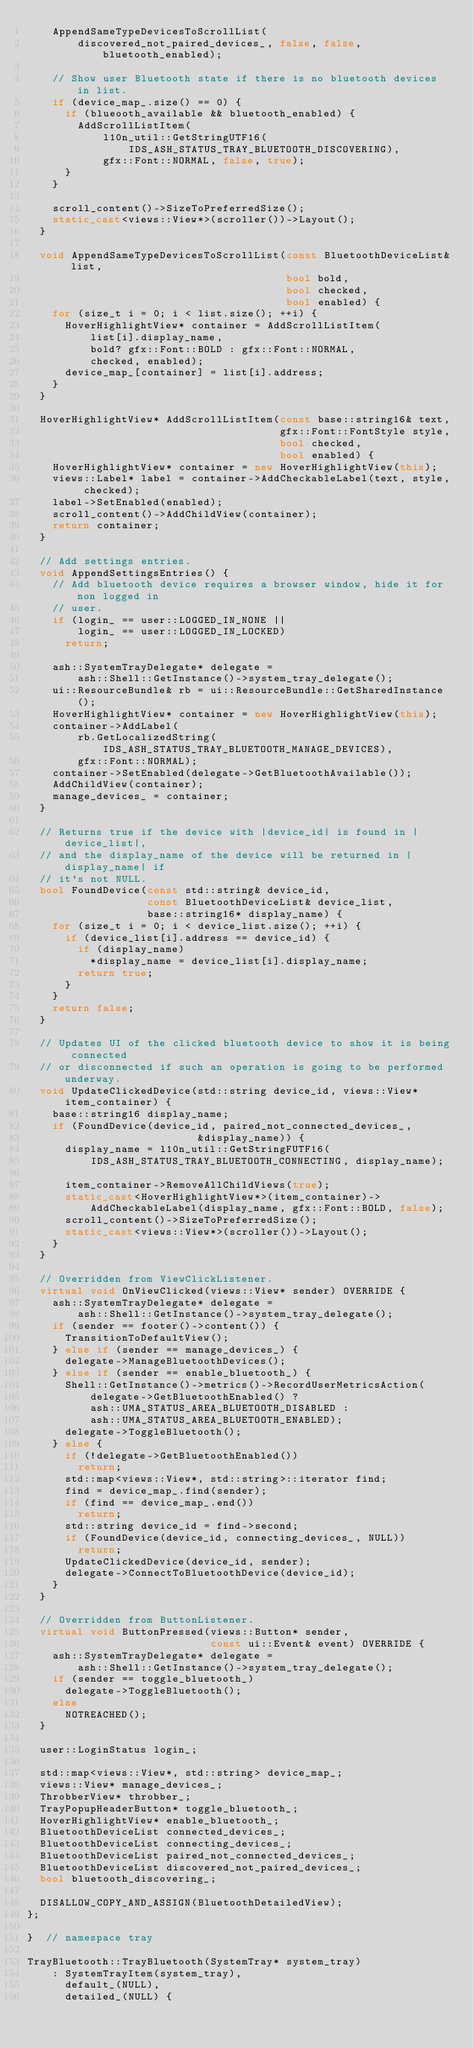<code> <loc_0><loc_0><loc_500><loc_500><_C++_>    AppendSameTypeDevicesToScrollList(
        discovered_not_paired_devices_, false, false, bluetooth_enabled);

    // Show user Bluetooth state if there is no bluetooth devices in list.
    if (device_map_.size() == 0) {
      if (blueooth_available && bluetooth_enabled) {
        AddScrollListItem(
            l10n_util::GetStringUTF16(
                IDS_ASH_STATUS_TRAY_BLUETOOTH_DISCOVERING),
            gfx::Font::NORMAL, false, true);
      }
    }

    scroll_content()->SizeToPreferredSize();
    static_cast<views::View*>(scroller())->Layout();
  }

  void AppendSameTypeDevicesToScrollList(const BluetoothDeviceList& list,
                                         bool bold,
                                         bool checked,
                                         bool enabled) {
    for (size_t i = 0; i < list.size(); ++i) {
      HoverHighlightView* container = AddScrollListItem(
          list[i].display_name,
          bold? gfx::Font::BOLD : gfx::Font::NORMAL,
          checked, enabled);
      device_map_[container] = list[i].address;
    }
  }

  HoverHighlightView* AddScrollListItem(const base::string16& text,
                                        gfx::Font::FontStyle style,
                                        bool checked,
                                        bool enabled) {
    HoverHighlightView* container = new HoverHighlightView(this);
    views::Label* label = container->AddCheckableLabel(text, style, checked);
    label->SetEnabled(enabled);
    scroll_content()->AddChildView(container);
    return container;
  }

  // Add settings entries.
  void AppendSettingsEntries() {
    // Add bluetooth device requires a browser window, hide it for non logged in
    // user.
    if (login_ == user::LOGGED_IN_NONE ||
        login_ == user::LOGGED_IN_LOCKED)
      return;

    ash::SystemTrayDelegate* delegate =
        ash::Shell::GetInstance()->system_tray_delegate();
    ui::ResourceBundle& rb = ui::ResourceBundle::GetSharedInstance();
    HoverHighlightView* container = new HoverHighlightView(this);
    container->AddLabel(
        rb.GetLocalizedString(IDS_ASH_STATUS_TRAY_BLUETOOTH_MANAGE_DEVICES),
        gfx::Font::NORMAL);
    container->SetEnabled(delegate->GetBluetoothAvailable());
    AddChildView(container);
    manage_devices_ = container;
  }

  // Returns true if the device with |device_id| is found in |device_list|,
  // and the display_name of the device will be returned in |display_name| if
  // it's not NULL.
  bool FoundDevice(const std::string& device_id,
                   const BluetoothDeviceList& device_list,
                   base::string16* display_name) {
    for (size_t i = 0; i < device_list.size(); ++i) {
      if (device_list[i].address == device_id) {
        if (display_name)
          *display_name = device_list[i].display_name;
        return true;
      }
    }
    return false;
  }

  // Updates UI of the clicked bluetooth device to show it is being connected
  // or disconnected if such an operation is going to be performed underway.
  void UpdateClickedDevice(std::string device_id, views::View* item_container) {
    base::string16 display_name;
    if (FoundDevice(device_id, paired_not_connected_devices_,
                           &display_name)) {
      display_name = l10n_util::GetStringFUTF16(
          IDS_ASH_STATUS_TRAY_BLUETOOTH_CONNECTING, display_name);

      item_container->RemoveAllChildViews(true);
      static_cast<HoverHighlightView*>(item_container)->
          AddCheckableLabel(display_name, gfx::Font::BOLD, false);
      scroll_content()->SizeToPreferredSize();
      static_cast<views::View*>(scroller())->Layout();
    }
  }

  // Overridden from ViewClickListener.
  virtual void OnViewClicked(views::View* sender) OVERRIDE {
    ash::SystemTrayDelegate* delegate =
        ash::Shell::GetInstance()->system_tray_delegate();
    if (sender == footer()->content()) {
      TransitionToDefaultView();
    } else if (sender == manage_devices_) {
      delegate->ManageBluetoothDevices();
    } else if (sender == enable_bluetooth_) {
      Shell::GetInstance()->metrics()->RecordUserMetricsAction(
          delegate->GetBluetoothEnabled() ?
          ash::UMA_STATUS_AREA_BLUETOOTH_DISABLED :
          ash::UMA_STATUS_AREA_BLUETOOTH_ENABLED);
      delegate->ToggleBluetooth();
    } else {
      if (!delegate->GetBluetoothEnabled())
        return;
      std::map<views::View*, std::string>::iterator find;
      find = device_map_.find(sender);
      if (find == device_map_.end())
        return;
      std::string device_id = find->second;
      if (FoundDevice(device_id, connecting_devices_, NULL))
        return;
      UpdateClickedDevice(device_id, sender);
      delegate->ConnectToBluetoothDevice(device_id);
    }
  }

  // Overridden from ButtonListener.
  virtual void ButtonPressed(views::Button* sender,
                             const ui::Event& event) OVERRIDE {
    ash::SystemTrayDelegate* delegate =
        ash::Shell::GetInstance()->system_tray_delegate();
    if (sender == toggle_bluetooth_)
      delegate->ToggleBluetooth();
    else
      NOTREACHED();
  }

  user::LoginStatus login_;

  std::map<views::View*, std::string> device_map_;
  views::View* manage_devices_;
  ThrobberView* throbber_;
  TrayPopupHeaderButton* toggle_bluetooth_;
  HoverHighlightView* enable_bluetooth_;
  BluetoothDeviceList connected_devices_;
  BluetoothDeviceList connecting_devices_;
  BluetoothDeviceList paired_not_connected_devices_;
  BluetoothDeviceList discovered_not_paired_devices_;
  bool bluetooth_discovering_;

  DISALLOW_COPY_AND_ASSIGN(BluetoothDetailedView);
};

}  // namespace tray

TrayBluetooth::TrayBluetooth(SystemTray* system_tray)
    : SystemTrayItem(system_tray),
      default_(NULL),
      detailed_(NULL) {</code> 